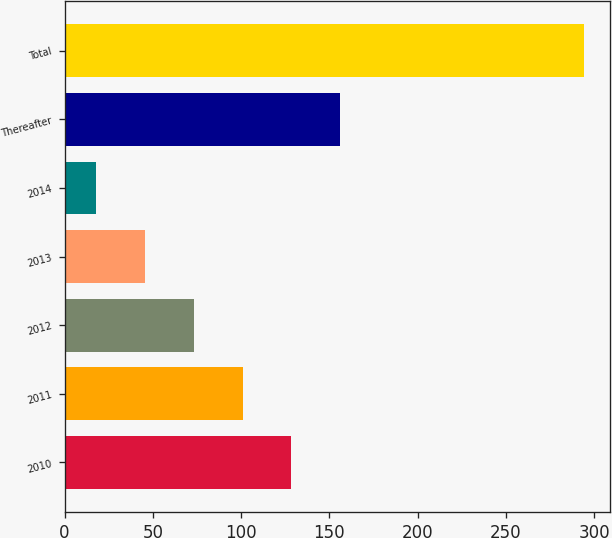Convert chart. <chart><loc_0><loc_0><loc_500><loc_500><bar_chart><fcel>2010<fcel>2011<fcel>2012<fcel>2013<fcel>2014<fcel>Thereafter<fcel>Total<nl><fcel>128.4<fcel>100.8<fcel>73.2<fcel>45.6<fcel>18<fcel>156<fcel>294<nl></chart> 